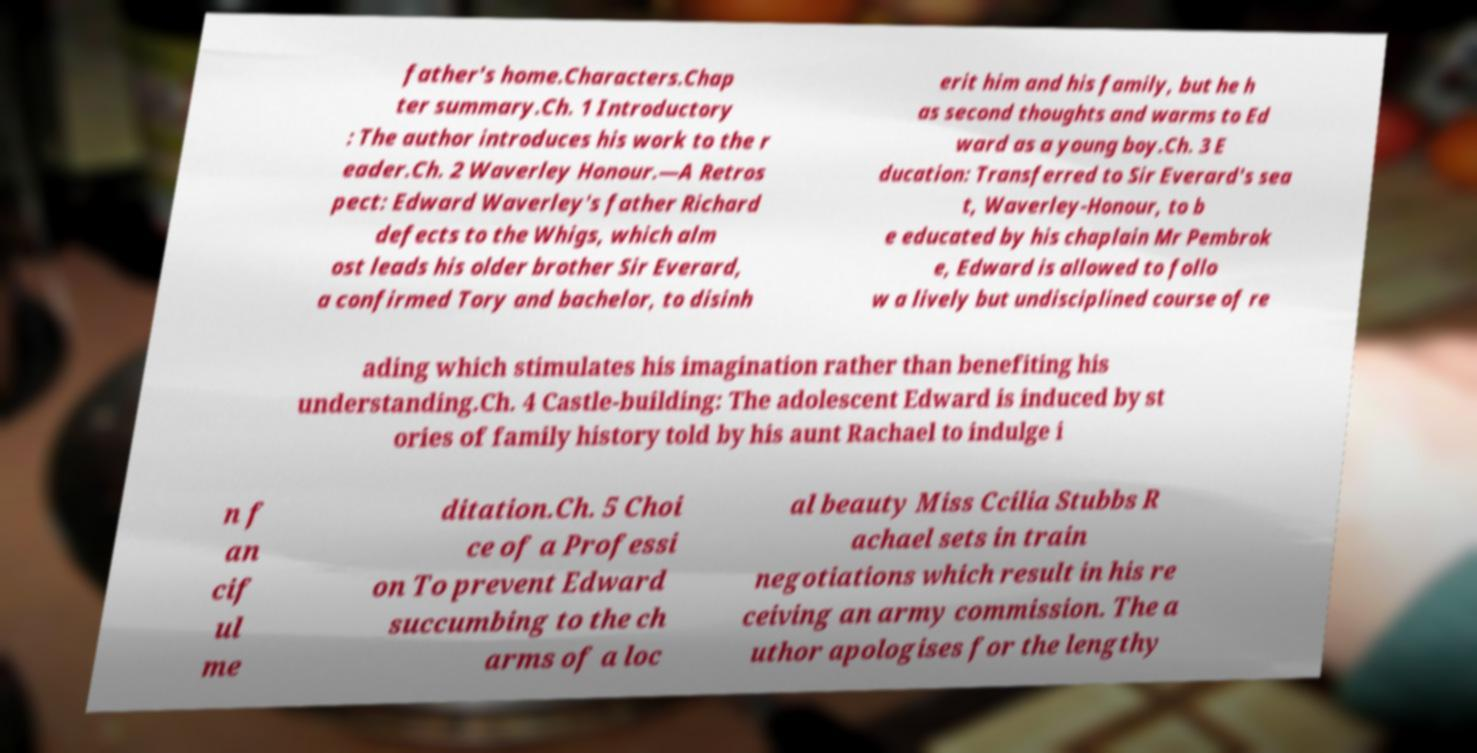Could you extract and type out the text from this image? father's home.Characters.Chap ter summary.Ch. 1 Introductory : The author introduces his work to the r eader.Ch. 2 Waverley Honour.—A Retros pect: Edward Waverley's father Richard defects to the Whigs, which alm ost leads his older brother Sir Everard, a confirmed Tory and bachelor, to disinh erit him and his family, but he h as second thoughts and warms to Ed ward as a young boy.Ch. 3 E ducation: Transferred to Sir Everard's sea t, Waverley-Honour, to b e educated by his chaplain Mr Pembrok e, Edward is allowed to follo w a lively but undisciplined course of re ading which stimulates his imagination rather than benefiting his understanding.Ch. 4 Castle-building: The adolescent Edward is induced by st ories of family history told by his aunt Rachael to indulge i n f an cif ul me ditation.Ch. 5 Choi ce of a Professi on To prevent Edward succumbing to the ch arms of a loc al beauty Miss Ccilia Stubbs R achael sets in train negotiations which result in his re ceiving an army commission. The a uthor apologises for the lengthy 